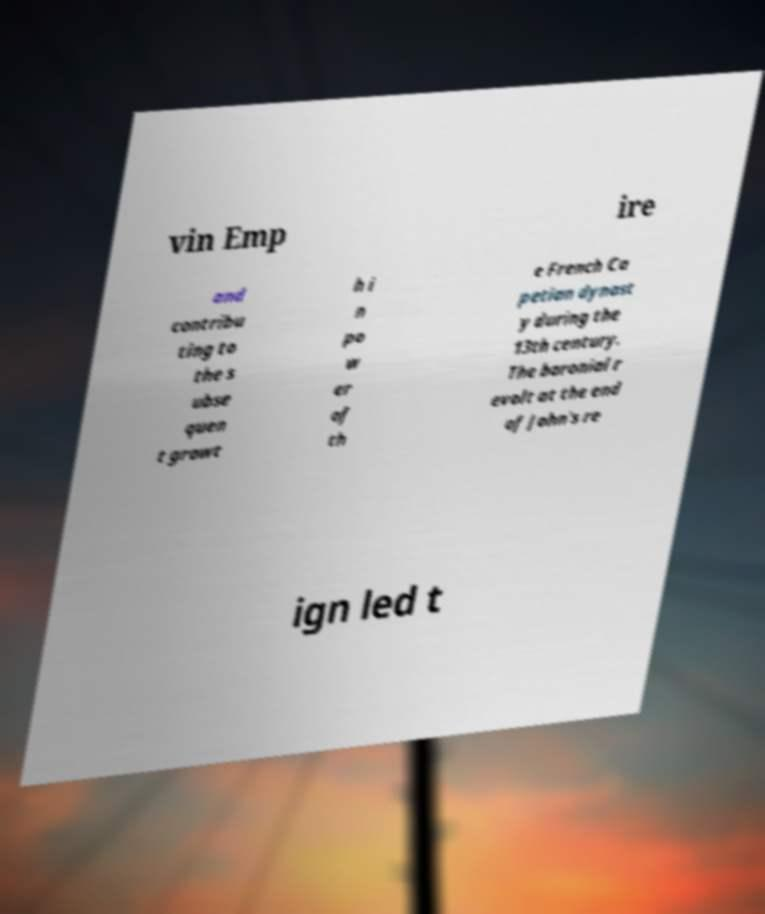Please read and relay the text visible in this image. What does it say? vin Emp ire and contribu ting to the s ubse quen t growt h i n po w er of th e French Ca petian dynast y during the 13th century. The baronial r evolt at the end of John's re ign led t 